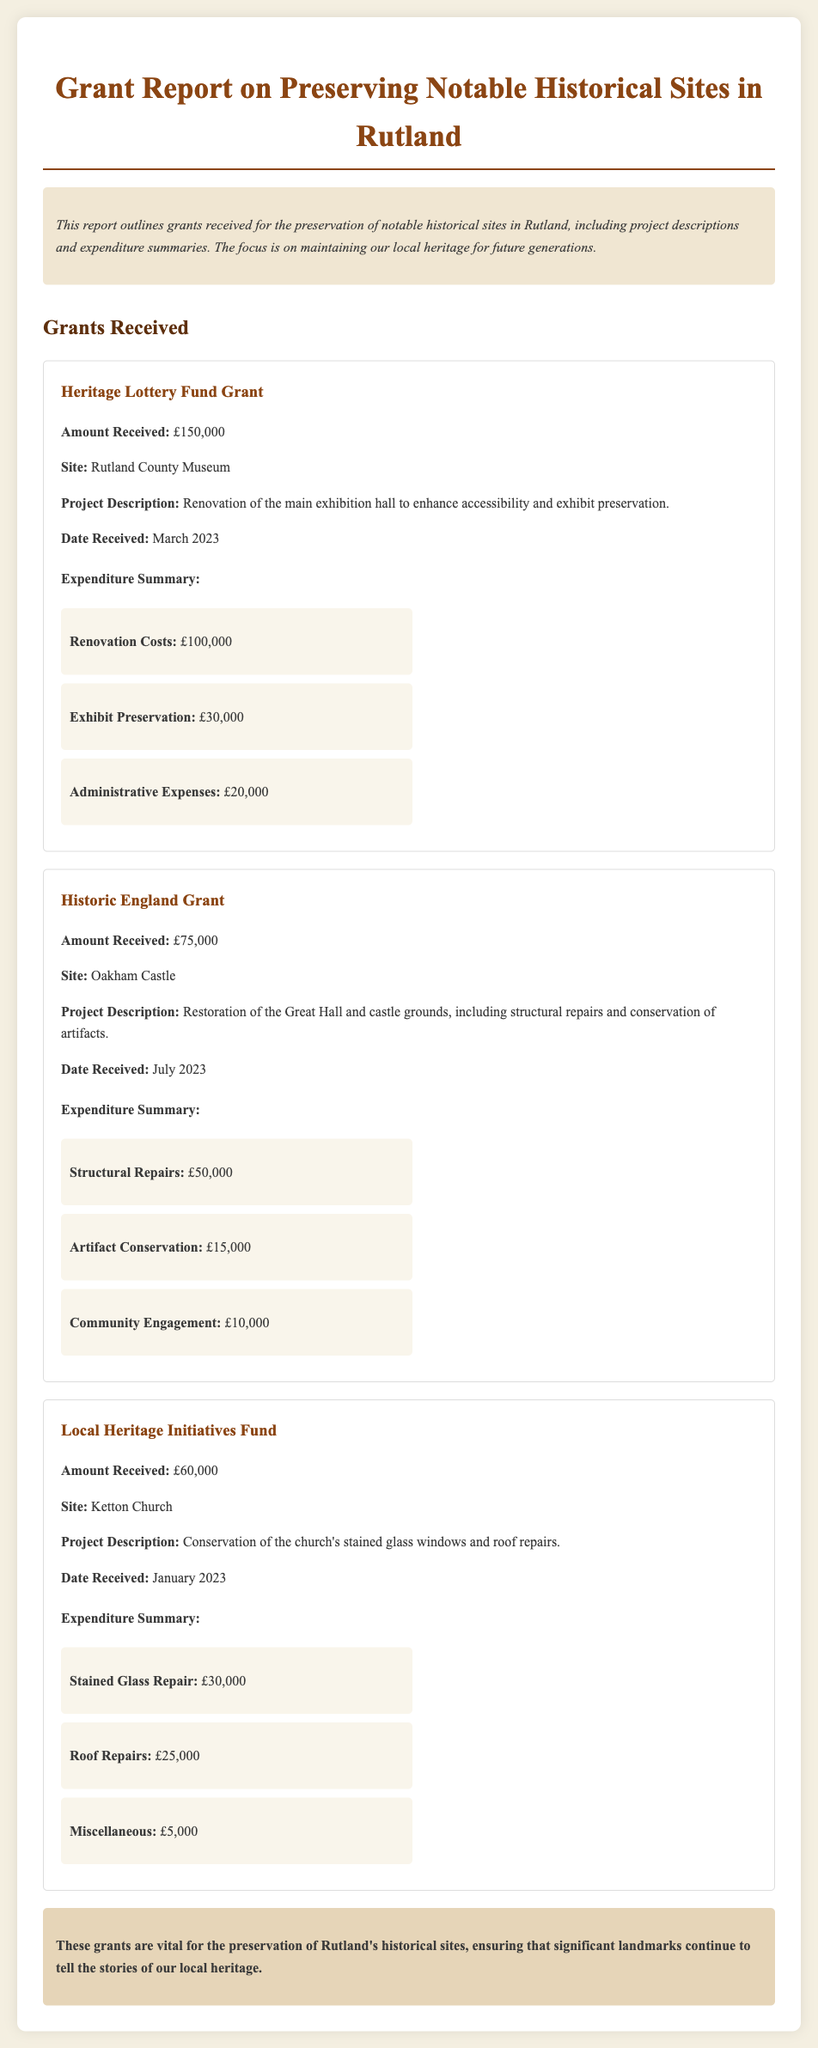what is the amount received from the Heritage Lottery Fund? The document states that the amount received from the Heritage Lottery Fund is £150,000.
Answer: £150,000 which site is associated with the Historic England Grant? According to the document, the site associated with the Historic England Grant is Oakham Castle.
Answer: Oakham Castle what is the total expenditure on renovation for the Rutland County Museum? The renovation costs for the Rutland County Museum total £100,000 as indicated in the expenditure summary.
Answer: £100,000 when was the grant for Ketton Church received? The document mentions that the grant for Ketton Church was received in January 2023.
Answer: January 2023 how much was allocated for community engagement in the Oakham Castle project? The document specifies that £10,000 was allocated for community engagement in the Oakham Castle project.
Answer: £10,000 what is the focus of this grant report? The report focuses on preserving notable historical sites in Rutland.
Answer: preserving notable historical sites in Rutland how much total funding was received for the Local Heritage Initiatives Fund project? The amount received for the Local Heritage Initiatives Fund project is £60,000, as mentioned in the document.
Answer: £60,000 what was the purpose of the project at Ketton Church? The document explains that the purpose of the project at Ketton Church was the conservation of stained glass windows and roof repairs.
Answer: conservation of stained glass windows and roof repairs what is the total amount of grants received listed in the report? The total amount of grants received listed in the report is £150,000 + £75,000 + £60,000 = £285,000.
Answer: £285,000 